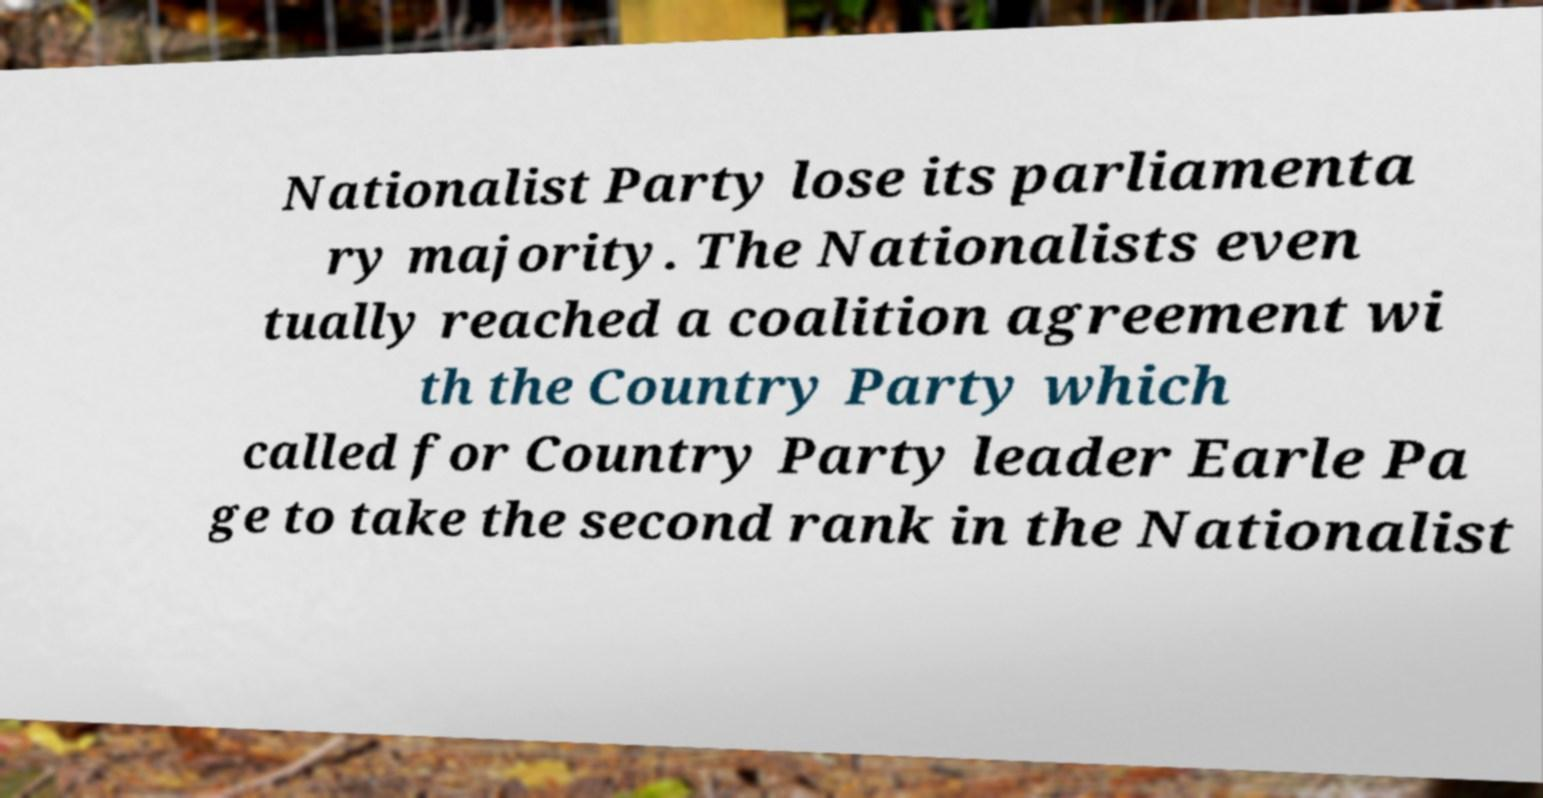Please identify and transcribe the text found in this image. Nationalist Party lose its parliamenta ry majority. The Nationalists even tually reached a coalition agreement wi th the Country Party which called for Country Party leader Earle Pa ge to take the second rank in the Nationalist 